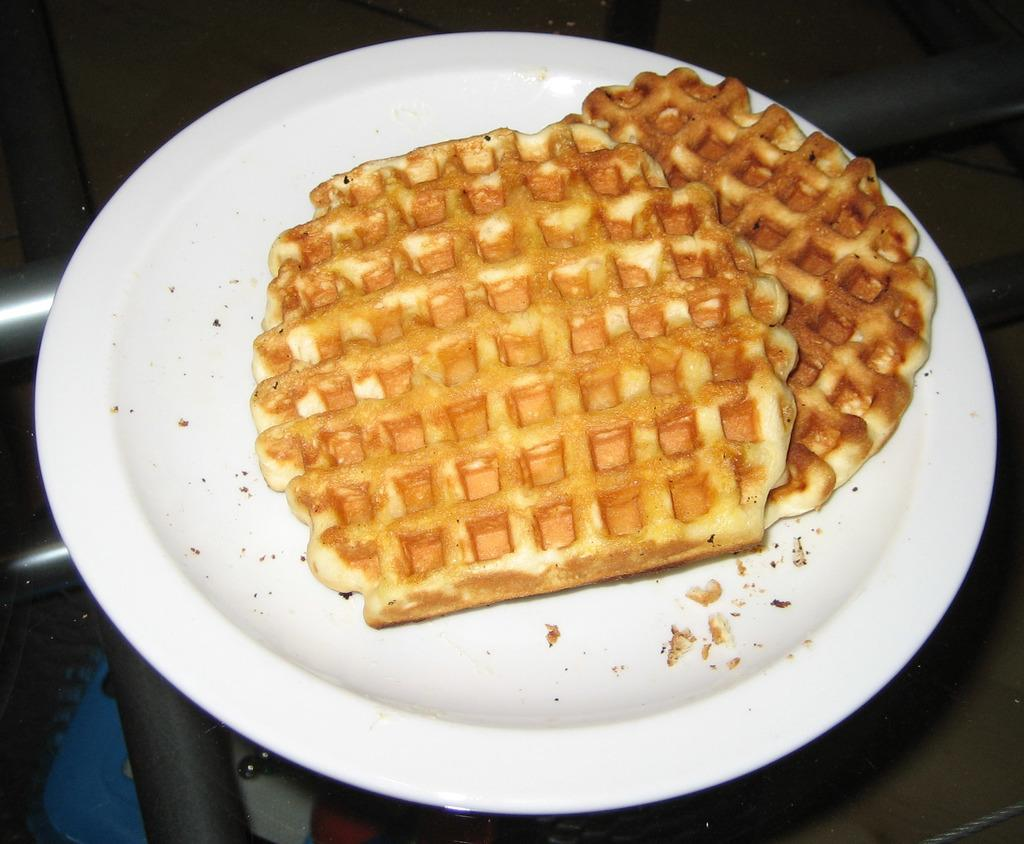What type of food is featured in the image? There are two waffles in the image. How are the waffles arranged or displayed? The waffles are on a white platter. What is the surface of the table that the platter is on? The platter is on a glass table. What country is the waffle originating from in the image? The image does not provide information about the origin of the waffles. 